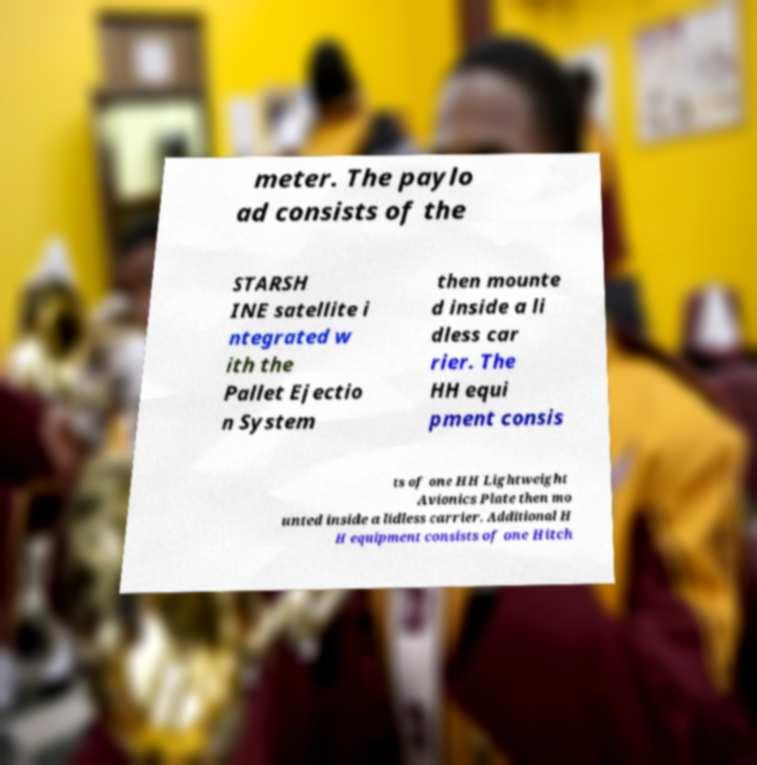Please identify and transcribe the text found in this image. meter. The paylo ad consists of the STARSH INE satellite i ntegrated w ith the Pallet Ejectio n System then mounte d inside a li dless car rier. The HH equi pment consis ts of one HH Lightweight Avionics Plate then mo unted inside a lidless carrier. Additional H H equipment consists of one Hitch 